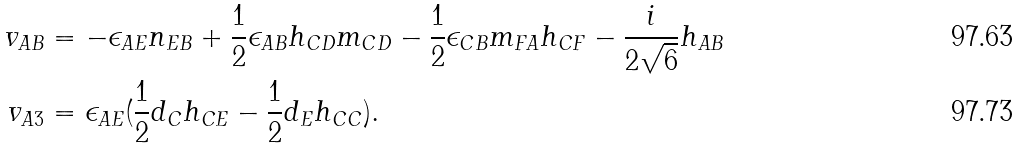Convert formula to latex. <formula><loc_0><loc_0><loc_500><loc_500>v _ { A B } & = - \epsilon _ { A E } n _ { E B } + \frac { 1 } { 2 } \epsilon _ { A B } h _ { C D } m _ { C D } - \frac { 1 } { 2 } \epsilon _ { C B } m _ { F A } h _ { C F } - \frac { i } { 2 \sqrt { 6 } } h _ { A B } \\ v _ { A 3 } & = \epsilon _ { A E } ( \frac { 1 } { 2 } d _ { C } h _ { C E } - \frac { 1 } { 2 } d _ { E } h _ { C C } ) .</formula> 